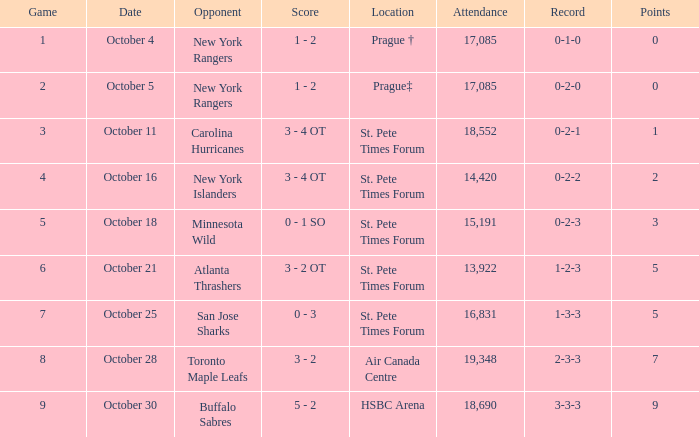What was the attendance when their record was at 0-2-2? 14420.0. 